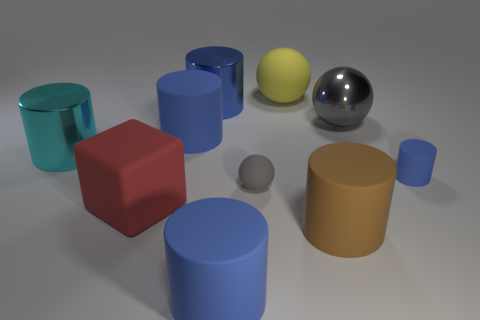How many blue cylinders must be subtracted to get 2 blue cylinders? 2 Subtract all red blocks. How many blue cylinders are left? 4 Subtract all brown cylinders. How many cylinders are left? 5 Subtract all big cyan cylinders. How many cylinders are left? 5 Subtract 1 cylinders. How many cylinders are left? 5 Subtract all purple cylinders. Subtract all gray blocks. How many cylinders are left? 6 Subtract all cubes. How many objects are left? 9 Subtract 1 yellow balls. How many objects are left? 9 Subtract all small blue rubber balls. Subtract all metallic balls. How many objects are left? 9 Add 5 red cubes. How many red cubes are left? 6 